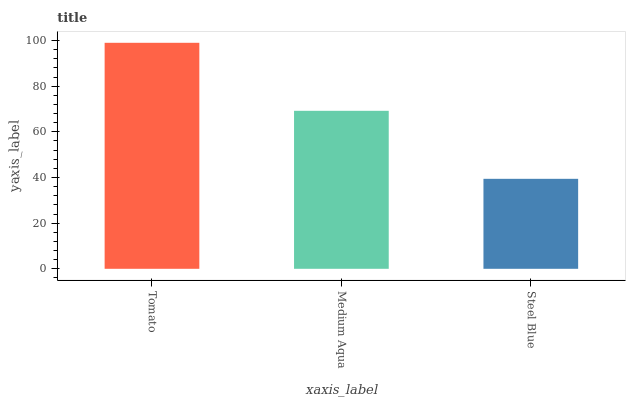Is Steel Blue the minimum?
Answer yes or no. Yes. Is Tomato the maximum?
Answer yes or no. Yes. Is Medium Aqua the minimum?
Answer yes or no. No. Is Medium Aqua the maximum?
Answer yes or no. No. Is Tomato greater than Medium Aqua?
Answer yes or no. Yes. Is Medium Aqua less than Tomato?
Answer yes or no. Yes. Is Medium Aqua greater than Tomato?
Answer yes or no. No. Is Tomato less than Medium Aqua?
Answer yes or no. No. Is Medium Aqua the high median?
Answer yes or no. Yes. Is Medium Aqua the low median?
Answer yes or no. Yes. Is Steel Blue the high median?
Answer yes or no. No. Is Tomato the low median?
Answer yes or no. No. 